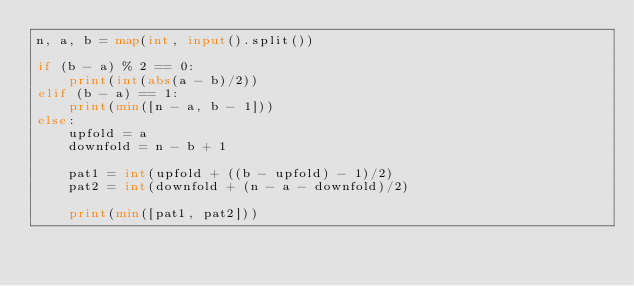<code> <loc_0><loc_0><loc_500><loc_500><_Python_>n, a, b = map(int, input().split())

if (b - a) % 2 == 0:
    print(int(abs(a - b)/2))
elif (b - a) == 1:
    print(min([n - a, b - 1]))
else:
    upfold = a
    downfold = n - b + 1

    pat1 = int(upfold + ((b - upfold) - 1)/2)
    pat2 = int(downfold + (n - a - downfold)/2)

    print(min([pat1, pat2]))</code> 